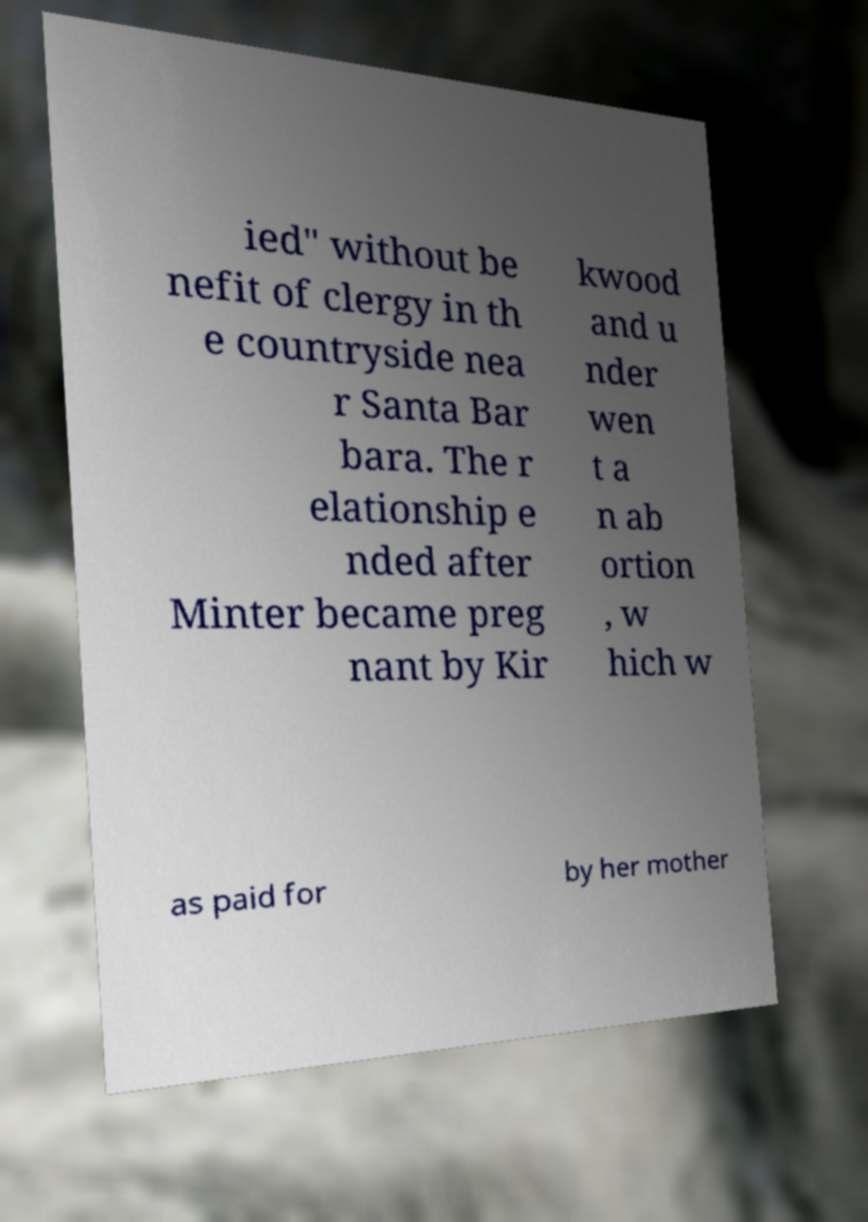There's text embedded in this image that I need extracted. Can you transcribe it verbatim? ied" without be nefit of clergy in th e countryside nea r Santa Bar bara. The r elationship e nded after Minter became preg nant by Kir kwood and u nder wen t a n ab ortion , w hich w as paid for by her mother 